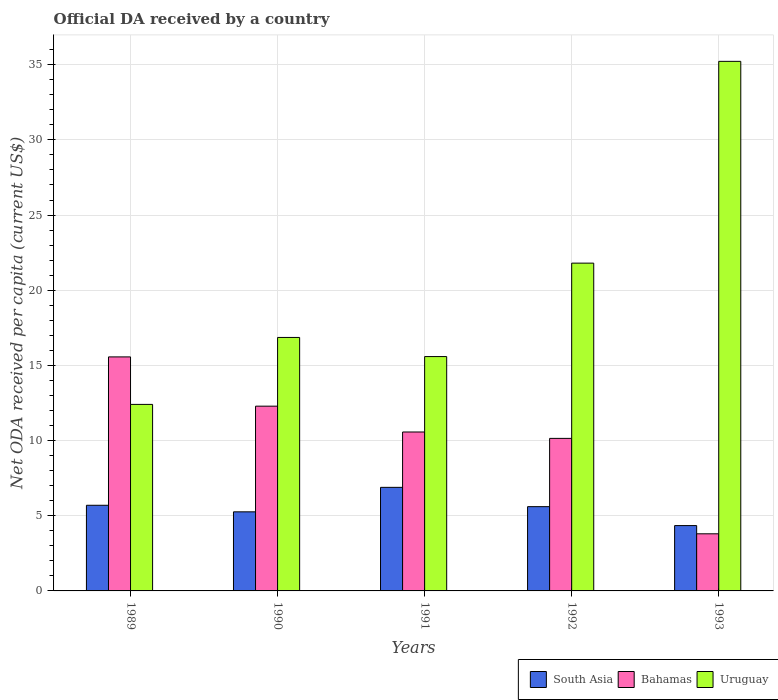How many groups of bars are there?
Your answer should be compact. 5. Are the number of bars per tick equal to the number of legend labels?
Make the answer very short. Yes. Are the number of bars on each tick of the X-axis equal?
Your response must be concise. Yes. How many bars are there on the 5th tick from the left?
Offer a very short reply. 3. How many bars are there on the 1st tick from the right?
Your response must be concise. 3. In how many cases, is the number of bars for a given year not equal to the number of legend labels?
Your answer should be very brief. 0. What is the ODA received in in Bahamas in 1989?
Your answer should be compact. 15.56. Across all years, what is the maximum ODA received in in Bahamas?
Provide a succinct answer. 15.56. Across all years, what is the minimum ODA received in in South Asia?
Your answer should be compact. 4.35. In which year was the ODA received in in Bahamas minimum?
Provide a succinct answer. 1993. What is the total ODA received in in Uruguay in the graph?
Ensure brevity in your answer.  101.87. What is the difference between the ODA received in in Bahamas in 1990 and that in 1993?
Your answer should be very brief. 8.49. What is the difference between the ODA received in in Bahamas in 1992 and the ODA received in in South Asia in 1990?
Your answer should be compact. 4.89. What is the average ODA received in in Uruguay per year?
Provide a short and direct response. 20.37. In the year 1991, what is the difference between the ODA received in in South Asia and ODA received in in Uruguay?
Make the answer very short. -8.7. What is the ratio of the ODA received in in Bahamas in 1989 to that in 1991?
Ensure brevity in your answer.  1.47. Is the ODA received in in South Asia in 1991 less than that in 1992?
Your response must be concise. No. What is the difference between the highest and the second highest ODA received in in Uruguay?
Offer a very short reply. 13.42. What is the difference between the highest and the lowest ODA received in in Bahamas?
Your answer should be very brief. 11.77. In how many years, is the ODA received in in Bahamas greater than the average ODA received in in Bahamas taken over all years?
Give a very brief answer. 3. Is the sum of the ODA received in in South Asia in 1989 and 1991 greater than the maximum ODA received in in Uruguay across all years?
Offer a very short reply. No. What does the 2nd bar from the left in 1990 represents?
Your answer should be very brief. Bahamas. What does the 2nd bar from the right in 1990 represents?
Your response must be concise. Bahamas. How many bars are there?
Provide a short and direct response. 15. Are all the bars in the graph horizontal?
Offer a terse response. No. Are the values on the major ticks of Y-axis written in scientific E-notation?
Provide a succinct answer. No. Does the graph contain any zero values?
Provide a succinct answer. No. Where does the legend appear in the graph?
Make the answer very short. Bottom right. How many legend labels are there?
Your response must be concise. 3. What is the title of the graph?
Make the answer very short. Official DA received by a country. Does "Afghanistan" appear as one of the legend labels in the graph?
Your answer should be very brief. No. What is the label or title of the X-axis?
Ensure brevity in your answer.  Years. What is the label or title of the Y-axis?
Make the answer very short. Net ODA received per capita (current US$). What is the Net ODA received per capita (current US$) of South Asia in 1989?
Provide a succinct answer. 5.7. What is the Net ODA received per capita (current US$) of Bahamas in 1989?
Provide a short and direct response. 15.56. What is the Net ODA received per capita (current US$) in Uruguay in 1989?
Ensure brevity in your answer.  12.41. What is the Net ODA received per capita (current US$) in South Asia in 1990?
Ensure brevity in your answer.  5.26. What is the Net ODA received per capita (current US$) in Bahamas in 1990?
Provide a short and direct response. 12.29. What is the Net ODA received per capita (current US$) of Uruguay in 1990?
Offer a very short reply. 16.86. What is the Net ODA received per capita (current US$) in South Asia in 1991?
Make the answer very short. 6.89. What is the Net ODA received per capita (current US$) in Bahamas in 1991?
Keep it short and to the point. 10.57. What is the Net ODA received per capita (current US$) of Uruguay in 1991?
Your response must be concise. 15.59. What is the Net ODA received per capita (current US$) of South Asia in 1992?
Provide a succinct answer. 5.6. What is the Net ODA received per capita (current US$) in Bahamas in 1992?
Provide a short and direct response. 10.15. What is the Net ODA received per capita (current US$) in Uruguay in 1992?
Make the answer very short. 21.8. What is the Net ODA received per capita (current US$) of South Asia in 1993?
Offer a very short reply. 4.35. What is the Net ODA received per capita (current US$) of Bahamas in 1993?
Provide a short and direct response. 3.8. What is the Net ODA received per capita (current US$) in Uruguay in 1993?
Your response must be concise. 35.22. Across all years, what is the maximum Net ODA received per capita (current US$) in South Asia?
Your answer should be compact. 6.89. Across all years, what is the maximum Net ODA received per capita (current US$) in Bahamas?
Provide a succinct answer. 15.56. Across all years, what is the maximum Net ODA received per capita (current US$) of Uruguay?
Your answer should be very brief. 35.22. Across all years, what is the minimum Net ODA received per capita (current US$) in South Asia?
Offer a terse response. 4.35. Across all years, what is the minimum Net ODA received per capita (current US$) in Bahamas?
Make the answer very short. 3.8. Across all years, what is the minimum Net ODA received per capita (current US$) in Uruguay?
Your answer should be very brief. 12.41. What is the total Net ODA received per capita (current US$) in South Asia in the graph?
Provide a succinct answer. 27.8. What is the total Net ODA received per capita (current US$) in Bahamas in the graph?
Provide a short and direct response. 52.37. What is the total Net ODA received per capita (current US$) in Uruguay in the graph?
Give a very brief answer. 101.87. What is the difference between the Net ODA received per capita (current US$) of South Asia in 1989 and that in 1990?
Your response must be concise. 0.44. What is the difference between the Net ODA received per capita (current US$) of Bahamas in 1989 and that in 1990?
Ensure brevity in your answer.  3.28. What is the difference between the Net ODA received per capita (current US$) in Uruguay in 1989 and that in 1990?
Give a very brief answer. -4.45. What is the difference between the Net ODA received per capita (current US$) of South Asia in 1989 and that in 1991?
Keep it short and to the point. -1.19. What is the difference between the Net ODA received per capita (current US$) in Bahamas in 1989 and that in 1991?
Keep it short and to the point. 4.99. What is the difference between the Net ODA received per capita (current US$) in Uruguay in 1989 and that in 1991?
Make the answer very short. -3.18. What is the difference between the Net ODA received per capita (current US$) of South Asia in 1989 and that in 1992?
Provide a short and direct response. 0.09. What is the difference between the Net ODA received per capita (current US$) of Bahamas in 1989 and that in 1992?
Your response must be concise. 5.42. What is the difference between the Net ODA received per capita (current US$) in Uruguay in 1989 and that in 1992?
Your answer should be very brief. -9.4. What is the difference between the Net ODA received per capita (current US$) in South Asia in 1989 and that in 1993?
Your answer should be very brief. 1.35. What is the difference between the Net ODA received per capita (current US$) of Bahamas in 1989 and that in 1993?
Provide a succinct answer. 11.77. What is the difference between the Net ODA received per capita (current US$) in Uruguay in 1989 and that in 1993?
Give a very brief answer. -22.82. What is the difference between the Net ODA received per capita (current US$) in South Asia in 1990 and that in 1991?
Give a very brief answer. -1.63. What is the difference between the Net ODA received per capita (current US$) of Bahamas in 1990 and that in 1991?
Give a very brief answer. 1.72. What is the difference between the Net ODA received per capita (current US$) in Uruguay in 1990 and that in 1991?
Give a very brief answer. 1.27. What is the difference between the Net ODA received per capita (current US$) of South Asia in 1990 and that in 1992?
Ensure brevity in your answer.  -0.34. What is the difference between the Net ODA received per capita (current US$) in Bahamas in 1990 and that in 1992?
Provide a short and direct response. 2.14. What is the difference between the Net ODA received per capita (current US$) of Uruguay in 1990 and that in 1992?
Ensure brevity in your answer.  -4.94. What is the difference between the Net ODA received per capita (current US$) in South Asia in 1990 and that in 1993?
Your response must be concise. 0.91. What is the difference between the Net ODA received per capita (current US$) of Bahamas in 1990 and that in 1993?
Provide a succinct answer. 8.49. What is the difference between the Net ODA received per capita (current US$) in Uruguay in 1990 and that in 1993?
Offer a terse response. -18.36. What is the difference between the Net ODA received per capita (current US$) of South Asia in 1991 and that in 1992?
Give a very brief answer. 1.28. What is the difference between the Net ODA received per capita (current US$) in Bahamas in 1991 and that in 1992?
Keep it short and to the point. 0.42. What is the difference between the Net ODA received per capita (current US$) of Uruguay in 1991 and that in 1992?
Ensure brevity in your answer.  -6.21. What is the difference between the Net ODA received per capita (current US$) of South Asia in 1991 and that in 1993?
Ensure brevity in your answer.  2.54. What is the difference between the Net ODA received per capita (current US$) of Bahamas in 1991 and that in 1993?
Your answer should be very brief. 6.77. What is the difference between the Net ODA received per capita (current US$) of Uruguay in 1991 and that in 1993?
Ensure brevity in your answer.  -19.63. What is the difference between the Net ODA received per capita (current US$) of South Asia in 1992 and that in 1993?
Your response must be concise. 1.26. What is the difference between the Net ODA received per capita (current US$) in Bahamas in 1992 and that in 1993?
Offer a terse response. 6.35. What is the difference between the Net ODA received per capita (current US$) in Uruguay in 1992 and that in 1993?
Your answer should be very brief. -13.42. What is the difference between the Net ODA received per capita (current US$) in South Asia in 1989 and the Net ODA received per capita (current US$) in Bahamas in 1990?
Offer a terse response. -6.59. What is the difference between the Net ODA received per capita (current US$) in South Asia in 1989 and the Net ODA received per capita (current US$) in Uruguay in 1990?
Make the answer very short. -11.16. What is the difference between the Net ODA received per capita (current US$) of Bahamas in 1989 and the Net ODA received per capita (current US$) of Uruguay in 1990?
Provide a short and direct response. -1.29. What is the difference between the Net ODA received per capita (current US$) in South Asia in 1989 and the Net ODA received per capita (current US$) in Bahamas in 1991?
Provide a short and direct response. -4.87. What is the difference between the Net ODA received per capita (current US$) in South Asia in 1989 and the Net ODA received per capita (current US$) in Uruguay in 1991?
Your answer should be very brief. -9.89. What is the difference between the Net ODA received per capita (current US$) in Bahamas in 1989 and the Net ODA received per capita (current US$) in Uruguay in 1991?
Give a very brief answer. -0.02. What is the difference between the Net ODA received per capita (current US$) in South Asia in 1989 and the Net ODA received per capita (current US$) in Bahamas in 1992?
Keep it short and to the point. -4.45. What is the difference between the Net ODA received per capita (current US$) in South Asia in 1989 and the Net ODA received per capita (current US$) in Uruguay in 1992?
Your answer should be compact. -16.11. What is the difference between the Net ODA received per capita (current US$) in Bahamas in 1989 and the Net ODA received per capita (current US$) in Uruguay in 1992?
Your answer should be very brief. -6.24. What is the difference between the Net ODA received per capita (current US$) in South Asia in 1989 and the Net ODA received per capita (current US$) in Bahamas in 1993?
Make the answer very short. 1.9. What is the difference between the Net ODA received per capita (current US$) of South Asia in 1989 and the Net ODA received per capita (current US$) of Uruguay in 1993?
Your answer should be compact. -29.53. What is the difference between the Net ODA received per capita (current US$) of Bahamas in 1989 and the Net ODA received per capita (current US$) of Uruguay in 1993?
Provide a succinct answer. -19.66. What is the difference between the Net ODA received per capita (current US$) of South Asia in 1990 and the Net ODA received per capita (current US$) of Bahamas in 1991?
Make the answer very short. -5.31. What is the difference between the Net ODA received per capita (current US$) of South Asia in 1990 and the Net ODA received per capita (current US$) of Uruguay in 1991?
Your answer should be compact. -10.33. What is the difference between the Net ODA received per capita (current US$) in Bahamas in 1990 and the Net ODA received per capita (current US$) in Uruguay in 1991?
Your response must be concise. -3.3. What is the difference between the Net ODA received per capita (current US$) of South Asia in 1990 and the Net ODA received per capita (current US$) of Bahamas in 1992?
Provide a succinct answer. -4.89. What is the difference between the Net ODA received per capita (current US$) in South Asia in 1990 and the Net ODA received per capita (current US$) in Uruguay in 1992?
Your response must be concise. -16.54. What is the difference between the Net ODA received per capita (current US$) in Bahamas in 1990 and the Net ODA received per capita (current US$) in Uruguay in 1992?
Your response must be concise. -9.51. What is the difference between the Net ODA received per capita (current US$) in South Asia in 1990 and the Net ODA received per capita (current US$) in Bahamas in 1993?
Give a very brief answer. 1.46. What is the difference between the Net ODA received per capita (current US$) of South Asia in 1990 and the Net ODA received per capita (current US$) of Uruguay in 1993?
Your response must be concise. -29.96. What is the difference between the Net ODA received per capita (current US$) of Bahamas in 1990 and the Net ODA received per capita (current US$) of Uruguay in 1993?
Offer a very short reply. -22.93. What is the difference between the Net ODA received per capita (current US$) of South Asia in 1991 and the Net ODA received per capita (current US$) of Bahamas in 1992?
Provide a short and direct response. -3.26. What is the difference between the Net ODA received per capita (current US$) in South Asia in 1991 and the Net ODA received per capita (current US$) in Uruguay in 1992?
Ensure brevity in your answer.  -14.91. What is the difference between the Net ODA received per capita (current US$) of Bahamas in 1991 and the Net ODA received per capita (current US$) of Uruguay in 1992?
Your answer should be compact. -11.23. What is the difference between the Net ODA received per capita (current US$) in South Asia in 1991 and the Net ODA received per capita (current US$) in Bahamas in 1993?
Your answer should be compact. 3.09. What is the difference between the Net ODA received per capita (current US$) of South Asia in 1991 and the Net ODA received per capita (current US$) of Uruguay in 1993?
Offer a very short reply. -28.33. What is the difference between the Net ODA received per capita (current US$) in Bahamas in 1991 and the Net ODA received per capita (current US$) in Uruguay in 1993?
Make the answer very short. -24.65. What is the difference between the Net ODA received per capita (current US$) of South Asia in 1992 and the Net ODA received per capita (current US$) of Bahamas in 1993?
Your response must be concise. 1.81. What is the difference between the Net ODA received per capita (current US$) of South Asia in 1992 and the Net ODA received per capita (current US$) of Uruguay in 1993?
Your answer should be very brief. -29.62. What is the difference between the Net ODA received per capita (current US$) in Bahamas in 1992 and the Net ODA received per capita (current US$) in Uruguay in 1993?
Keep it short and to the point. -25.08. What is the average Net ODA received per capita (current US$) in South Asia per year?
Offer a terse response. 5.56. What is the average Net ODA received per capita (current US$) in Bahamas per year?
Keep it short and to the point. 10.47. What is the average Net ODA received per capita (current US$) of Uruguay per year?
Provide a short and direct response. 20.37. In the year 1989, what is the difference between the Net ODA received per capita (current US$) in South Asia and Net ODA received per capita (current US$) in Bahamas?
Provide a succinct answer. -9.87. In the year 1989, what is the difference between the Net ODA received per capita (current US$) of South Asia and Net ODA received per capita (current US$) of Uruguay?
Give a very brief answer. -6.71. In the year 1989, what is the difference between the Net ODA received per capita (current US$) of Bahamas and Net ODA received per capita (current US$) of Uruguay?
Provide a short and direct response. 3.16. In the year 1990, what is the difference between the Net ODA received per capita (current US$) of South Asia and Net ODA received per capita (current US$) of Bahamas?
Keep it short and to the point. -7.03. In the year 1990, what is the difference between the Net ODA received per capita (current US$) of South Asia and Net ODA received per capita (current US$) of Uruguay?
Offer a terse response. -11.6. In the year 1990, what is the difference between the Net ODA received per capita (current US$) in Bahamas and Net ODA received per capita (current US$) in Uruguay?
Offer a terse response. -4.57. In the year 1991, what is the difference between the Net ODA received per capita (current US$) in South Asia and Net ODA received per capita (current US$) in Bahamas?
Make the answer very short. -3.68. In the year 1991, what is the difference between the Net ODA received per capita (current US$) of South Asia and Net ODA received per capita (current US$) of Uruguay?
Your answer should be very brief. -8.7. In the year 1991, what is the difference between the Net ODA received per capita (current US$) of Bahamas and Net ODA received per capita (current US$) of Uruguay?
Provide a short and direct response. -5.02. In the year 1992, what is the difference between the Net ODA received per capita (current US$) of South Asia and Net ODA received per capita (current US$) of Bahamas?
Provide a short and direct response. -4.54. In the year 1992, what is the difference between the Net ODA received per capita (current US$) in South Asia and Net ODA received per capita (current US$) in Uruguay?
Make the answer very short. -16.2. In the year 1992, what is the difference between the Net ODA received per capita (current US$) in Bahamas and Net ODA received per capita (current US$) in Uruguay?
Offer a very short reply. -11.66. In the year 1993, what is the difference between the Net ODA received per capita (current US$) in South Asia and Net ODA received per capita (current US$) in Bahamas?
Make the answer very short. 0.55. In the year 1993, what is the difference between the Net ODA received per capita (current US$) in South Asia and Net ODA received per capita (current US$) in Uruguay?
Keep it short and to the point. -30.88. In the year 1993, what is the difference between the Net ODA received per capita (current US$) in Bahamas and Net ODA received per capita (current US$) in Uruguay?
Give a very brief answer. -31.42. What is the ratio of the Net ODA received per capita (current US$) of South Asia in 1989 to that in 1990?
Give a very brief answer. 1.08. What is the ratio of the Net ODA received per capita (current US$) in Bahamas in 1989 to that in 1990?
Offer a very short reply. 1.27. What is the ratio of the Net ODA received per capita (current US$) in Uruguay in 1989 to that in 1990?
Provide a succinct answer. 0.74. What is the ratio of the Net ODA received per capita (current US$) in South Asia in 1989 to that in 1991?
Your answer should be compact. 0.83. What is the ratio of the Net ODA received per capita (current US$) in Bahamas in 1989 to that in 1991?
Offer a terse response. 1.47. What is the ratio of the Net ODA received per capita (current US$) in Uruguay in 1989 to that in 1991?
Provide a succinct answer. 0.8. What is the ratio of the Net ODA received per capita (current US$) in South Asia in 1989 to that in 1992?
Keep it short and to the point. 1.02. What is the ratio of the Net ODA received per capita (current US$) in Bahamas in 1989 to that in 1992?
Ensure brevity in your answer.  1.53. What is the ratio of the Net ODA received per capita (current US$) in Uruguay in 1989 to that in 1992?
Offer a terse response. 0.57. What is the ratio of the Net ODA received per capita (current US$) of South Asia in 1989 to that in 1993?
Your answer should be very brief. 1.31. What is the ratio of the Net ODA received per capita (current US$) in Bahamas in 1989 to that in 1993?
Your answer should be compact. 4.1. What is the ratio of the Net ODA received per capita (current US$) in Uruguay in 1989 to that in 1993?
Your response must be concise. 0.35. What is the ratio of the Net ODA received per capita (current US$) in South Asia in 1990 to that in 1991?
Make the answer very short. 0.76. What is the ratio of the Net ODA received per capita (current US$) of Bahamas in 1990 to that in 1991?
Provide a short and direct response. 1.16. What is the ratio of the Net ODA received per capita (current US$) in Uruguay in 1990 to that in 1991?
Give a very brief answer. 1.08. What is the ratio of the Net ODA received per capita (current US$) in South Asia in 1990 to that in 1992?
Provide a succinct answer. 0.94. What is the ratio of the Net ODA received per capita (current US$) of Bahamas in 1990 to that in 1992?
Your response must be concise. 1.21. What is the ratio of the Net ODA received per capita (current US$) of Uruguay in 1990 to that in 1992?
Offer a terse response. 0.77. What is the ratio of the Net ODA received per capita (current US$) of South Asia in 1990 to that in 1993?
Keep it short and to the point. 1.21. What is the ratio of the Net ODA received per capita (current US$) in Bahamas in 1990 to that in 1993?
Give a very brief answer. 3.24. What is the ratio of the Net ODA received per capita (current US$) in Uruguay in 1990 to that in 1993?
Offer a terse response. 0.48. What is the ratio of the Net ODA received per capita (current US$) of South Asia in 1991 to that in 1992?
Offer a terse response. 1.23. What is the ratio of the Net ODA received per capita (current US$) in Bahamas in 1991 to that in 1992?
Make the answer very short. 1.04. What is the ratio of the Net ODA received per capita (current US$) in Uruguay in 1991 to that in 1992?
Offer a terse response. 0.71. What is the ratio of the Net ODA received per capita (current US$) of South Asia in 1991 to that in 1993?
Provide a succinct answer. 1.59. What is the ratio of the Net ODA received per capita (current US$) in Bahamas in 1991 to that in 1993?
Provide a succinct answer. 2.78. What is the ratio of the Net ODA received per capita (current US$) in Uruguay in 1991 to that in 1993?
Make the answer very short. 0.44. What is the ratio of the Net ODA received per capita (current US$) in South Asia in 1992 to that in 1993?
Offer a very short reply. 1.29. What is the ratio of the Net ODA received per capita (current US$) in Bahamas in 1992 to that in 1993?
Ensure brevity in your answer.  2.67. What is the ratio of the Net ODA received per capita (current US$) of Uruguay in 1992 to that in 1993?
Your answer should be very brief. 0.62. What is the difference between the highest and the second highest Net ODA received per capita (current US$) of South Asia?
Provide a succinct answer. 1.19. What is the difference between the highest and the second highest Net ODA received per capita (current US$) in Bahamas?
Provide a succinct answer. 3.28. What is the difference between the highest and the second highest Net ODA received per capita (current US$) of Uruguay?
Make the answer very short. 13.42. What is the difference between the highest and the lowest Net ODA received per capita (current US$) of South Asia?
Give a very brief answer. 2.54. What is the difference between the highest and the lowest Net ODA received per capita (current US$) of Bahamas?
Ensure brevity in your answer.  11.77. What is the difference between the highest and the lowest Net ODA received per capita (current US$) of Uruguay?
Your answer should be compact. 22.82. 